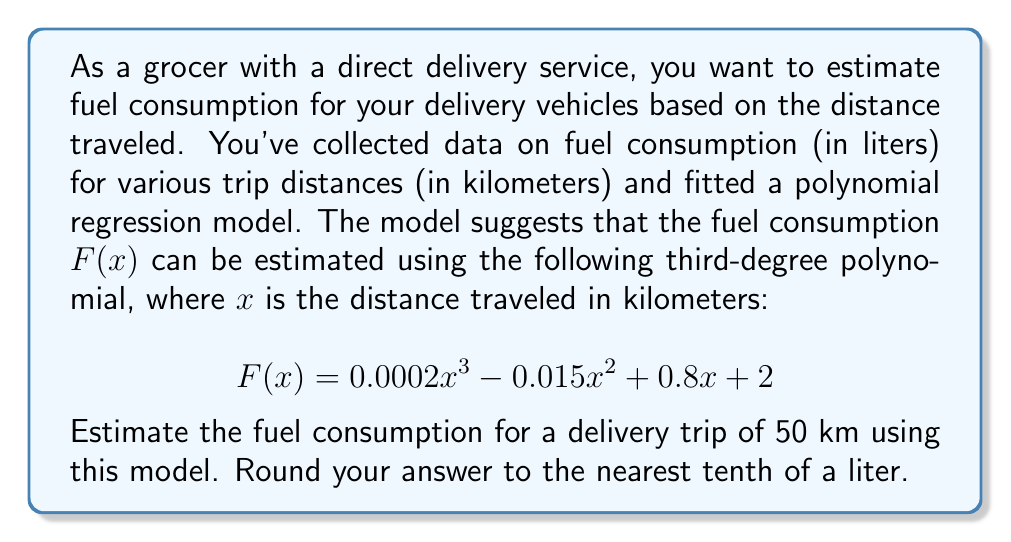Solve this math problem. To solve this problem, we need to follow these steps:

1. Identify the given polynomial function:
   $$F(x) = 0.0002x^3 - 0.015x^2 + 0.8x + 2$$

2. Substitute $x = 50$ into the function:
   $$F(50) = 0.0002(50)^3 - 0.015(50)^2 + 0.8(50) + 2$$

3. Calculate each term:
   - $0.0002(50)^3 = 0.0002 \times 125000 = 25$
   - $-0.015(50)^2 = -0.015 \times 2500 = -37.5$
   - $0.8(50) = 40$
   - The constant term is 2

4. Sum up all the terms:
   $$F(50) = 25 - 37.5 + 40 + 2 = 29.5$$

5. Round the result to the nearest tenth:
   $29.5$ rounds to $29.5$ liters

Therefore, the estimated fuel consumption for a 50 km delivery trip is 29.5 liters.
Answer: 29.5 liters 